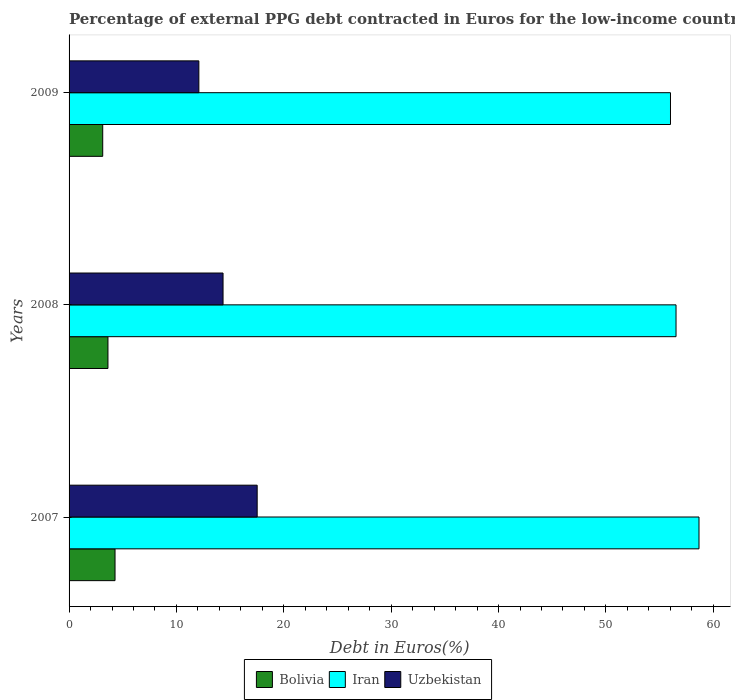How many different coloured bars are there?
Give a very brief answer. 3. How many bars are there on the 1st tick from the bottom?
Offer a very short reply. 3. In how many cases, is the number of bars for a given year not equal to the number of legend labels?
Your response must be concise. 0. What is the percentage of external PPG debt contracted in Euros in Bolivia in 2008?
Ensure brevity in your answer.  3.62. Across all years, what is the maximum percentage of external PPG debt contracted in Euros in Uzbekistan?
Ensure brevity in your answer.  17.52. Across all years, what is the minimum percentage of external PPG debt contracted in Euros in Iran?
Provide a succinct answer. 56.01. In which year was the percentage of external PPG debt contracted in Euros in Bolivia minimum?
Keep it short and to the point. 2009. What is the total percentage of external PPG debt contracted in Euros in Uzbekistan in the graph?
Ensure brevity in your answer.  43.95. What is the difference between the percentage of external PPG debt contracted in Euros in Uzbekistan in 2007 and that in 2008?
Your response must be concise. 3.18. What is the difference between the percentage of external PPG debt contracted in Euros in Iran in 2009 and the percentage of external PPG debt contracted in Euros in Bolivia in 2007?
Your response must be concise. 51.73. What is the average percentage of external PPG debt contracted in Euros in Iran per year?
Provide a short and direct response. 57.07. In the year 2007, what is the difference between the percentage of external PPG debt contracted in Euros in Bolivia and percentage of external PPG debt contracted in Euros in Iran?
Provide a succinct answer. -54.39. In how many years, is the percentage of external PPG debt contracted in Euros in Uzbekistan greater than 42 %?
Ensure brevity in your answer.  0. What is the ratio of the percentage of external PPG debt contracted in Euros in Iran in 2008 to that in 2009?
Ensure brevity in your answer.  1.01. Is the difference between the percentage of external PPG debt contracted in Euros in Bolivia in 2007 and 2009 greater than the difference between the percentage of external PPG debt contracted in Euros in Iran in 2007 and 2009?
Provide a short and direct response. No. What is the difference between the highest and the second highest percentage of external PPG debt contracted in Euros in Iran?
Your response must be concise. 2.14. What is the difference between the highest and the lowest percentage of external PPG debt contracted in Euros in Uzbekistan?
Offer a very short reply. 5.43. In how many years, is the percentage of external PPG debt contracted in Euros in Iran greater than the average percentage of external PPG debt contracted in Euros in Iran taken over all years?
Your answer should be very brief. 1. Is the sum of the percentage of external PPG debt contracted in Euros in Uzbekistan in 2008 and 2009 greater than the maximum percentage of external PPG debt contracted in Euros in Iran across all years?
Offer a very short reply. No. What does the 2nd bar from the top in 2008 represents?
Your answer should be compact. Iran. What does the 1st bar from the bottom in 2009 represents?
Your answer should be compact. Bolivia. Are all the bars in the graph horizontal?
Your response must be concise. Yes. How many years are there in the graph?
Provide a short and direct response. 3. What is the difference between two consecutive major ticks on the X-axis?
Your answer should be compact. 10. Are the values on the major ticks of X-axis written in scientific E-notation?
Provide a succinct answer. No. Does the graph contain any zero values?
Your answer should be compact. No. Where does the legend appear in the graph?
Your response must be concise. Bottom center. How many legend labels are there?
Keep it short and to the point. 3. How are the legend labels stacked?
Provide a short and direct response. Horizontal. What is the title of the graph?
Give a very brief answer. Percentage of external PPG debt contracted in Euros for the low-income countries. Does "Sub-Saharan Africa (developing only)" appear as one of the legend labels in the graph?
Your response must be concise. No. What is the label or title of the X-axis?
Offer a terse response. Debt in Euros(%). What is the Debt in Euros(%) in Bolivia in 2007?
Offer a terse response. 4.28. What is the Debt in Euros(%) of Iran in 2007?
Ensure brevity in your answer.  58.67. What is the Debt in Euros(%) in Uzbekistan in 2007?
Provide a succinct answer. 17.52. What is the Debt in Euros(%) of Bolivia in 2008?
Offer a very short reply. 3.62. What is the Debt in Euros(%) in Iran in 2008?
Make the answer very short. 56.53. What is the Debt in Euros(%) of Uzbekistan in 2008?
Give a very brief answer. 14.34. What is the Debt in Euros(%) of Bolivia in 2009?
Offer a very short reply. 3.13. What is the Debt in Euros(%) in Iran in 2009?
Your response must be concise. 56.01. What is the Debt in Euros(%) of Uzbekistan in 2009?
Offer a terse response. 12.09. Across all years, what is the maximum Debt in Euros(%) in Bolivia?
Give a very brief answer. 4.28. Across all years, what is the maximum Debt in Euros(%) in Iran?
Ensure brevity in your answer.  58.67. Across all years, what is the maximum Debt in Euros(%) in Uzbekistan?
Offer a very short reply. 17.52. Across all years, what is the minimum Debt in Euros(%) of Bolivia?
Make the answer very short. 3.13. Across all years, what is the minimum Debt in Euros(%) in Iran?
Give a very brief answer. 56.01. Across all years, what is the minimum Debt in Euros(%) of Uzbekistan?
Keep it short and to the point. 12.09. What is the total Debt in Euros(%) in Bolivia in the graph?
Your response must be concise. 11.04. What is the total Debt in Euros(%) of Iran in the graph?
Your answer should be compact. 171.21. What is the total Debt in Euros(%) in Uzbekistan in the graph?
Provide a succinct answer. 43.95. What is the difference between the Debt in Euros(%) in Bolivia in 2007 and that in 2008?
Provide a short and direct response. 0.66. What is the difference between the Debt in Euros(%) of Iran in 2007 and that in 2008?
Offer a very short reply. 2.14. What is the difference between the Debt in Euros(%) in Uzbekistan in 2007 and that in 2008?
Make the answer very short. 3.18. What is the difference between the Debt in Euros(%) in Bolivia in 2007 and that in 2009?
Ensure brevity in your answer.  1.15. What is the difference between the Debt in Euros(%) in Iran in 2007 and that in 2009?
Provide a short and direct response. 2.66. What is the difference between the Debt in Euros(%) in Uzbekistan in 2007 and that in 2009?
Provide a succinct answer. 5.43. What is the difference between the Debt in Euros(%) in Bolivia in 2008 and that in 2009?
Provide a short and direct response. 0.49. What is the difference between the Debt in Euros(%) of Iran in 2008 and that in 2009?
Your answer should be compact. 0.52. What is the difference between the Debt in Euros(%) of Uzbekistan in 2008 and that in 2009?
Make the answer very short. 2.25. What is the difference between the Debt in Euros(%) of Bolivia in 2007 and the Debt in Euros(%) of Iran in 2008?
Provide a short and direct response. -52.25. What is the difference between the Debt in Euros(%) in Bolivia in 2007 and the Debt in Euros(%) in Uzbekistan in 2008?
Make the answer very short. -10.06. What is the difference between the Debt in Euros(%) of Iran in 2007 and the Debt in Euros(%) of Uzbekistan in 2008?
Make the answer very short. 44.33. What is the difference between the Debt in Euros(%) of Bolivia in 2007 and the Debt in Euros(%) of Iran in 2009?
Offer a very short reply. -51.73. What is the difference between the Debt in Euros(%) in Bolivia in 2007 and the Debt in Euros(%) in Uzbekistan in 2009?
Give a very brief answer. -7.81. What is the difference between the Debt in Euros(%) of Iran in 2007 and the Debt in Euros(%) of Uzbekistan in 2009?
Your answer should be compact. 46.58. What is the difference between the Debt in Euros(%) in Bolivia in 2008 and the Debt in Euros(%) in Iran in 2009?
Make the answer very short. -52.39. What is the difference between the Debt in Euros(%) in Bolivia in 2008 and the Debt in Euros(%) in Uzbekistan in 2009?
Offer a very short reply. -8.47. What is the difference between the Debt in Euros(%) in Iran in 2008 and the Debt in Euros(%) in Uzbekistan in 2009?
Offer a very short reply. 44.44. What is the average Debt in Euros(%) in Bolivia per year?
Make the answer very short. 3.68. What is the average Debt in Euros(%) of Iran per year?
Your answer should be compact. 57.07. What is the average Debt in Euros(%) in Uzbekistan per year?
Your answer should be compact. 14.65. In the year 2007, what is the difference between the Debt in Euros(%) in Bolivia and Debt in Euros(%) in Iran?
Your answer should be very brief. -54.39. In the year 2007, what is the difference between the Debt in Euros(%) in Bolivia and Debt in Euros(%) in Uzbekistan?
Provide a succinct answer. -13.24. In the year 2007, what is the difference between the Debt in Euros(%) of Iran and Debt in Euros(%) of Uzbekistan?
Offer a terse response. 41.15. In the year 2008, what is the difference between the Debt in Euros(%) of Bolivia and Debt in Euros(%) of Iran?
Keep it short and to the point. -52.91. In the year 2008, what is the difference between the Debt in Euros(%) of Bolivia and Debt in Euros(%) of Uzbekistan?
Provide a short and direct response. -10.72. In the year 2008, what is the difference between the Debt in Euros(%) in Iran and Debt in Euros(%) in Uzbekistan?
Your answer should be very brief. 42.19. In the year 2009, what is the difference between the Debt in Euros(%) in Bolivia and Debt in Euros(%) in Iran?
Keep it short and to the point. -52.88. In the year 2009, what is the difference between the Debt in Euros(%) in Bolivia and Debt in Euros(%) in Uzbekistan?
Ensure brevity in your answer.  -8.95. In the year 2009, what is the difference between the Debt in Euros(%) in Iran and Debt in Euros(%) in Uzbekistan?
Provide a succinct answer. 43.93. What is the ratio of the Debt in Euros(%) of Bolivia in 2007 to that in 2008?
Provide a succinct answer. 1.18. What is the ratio of the Debt in Euros(%) of Iran in 2007 to that in 2008?
Keep it short and to the point. 1.04. What is the ratio of the Debt in Euros(%) in Uzbekistan in 2007 to that in 2008?
Offer a terse response. 1.22. What is the ratio of the Debt in Euros(%) in Bolivia in 2007 to that in 2009?
Give a very brief answer. 1.37. What is the ratio of the Debt in Euros(%) in Iran in 2007 to that in 2009?
Your answer should be very brief. 1.05. What is the ratio of the Debt in Euros(%) of Uzbekistan in 2007 to that in 2009?
Give a very brief answer. 1.45. What is the ratio of the Debt in Euros(%) in Bolivia in 2008 to that in 2009?
Ensure brevity in your answer.  1.16. What is the ratio of the Debt in Euros(%) in Iran in 2008 to that in 2009?
Provide a short and direct response. 1.01. What is the ratio of the Debt in Euros(%) in Uzbekistan in 2008 to that in 2009?
Make the answer very short. 1.19. What is the difference between the highest and the second highest Debt in Euros(%) in Bolivia?
Give a very brief answer. 0.66. What is the difference between the highest and the second highest Debt in Euros(%) of Iran?
Give a very brief answer. 2.14. What is the difference between the highest and the second highest Debt in Euros(%) of Uzbekistan?
Make the answer very short. 3.18. What is the difference between the highest and the lowest Debt in Euros(%) of Bolivia?
Your answer should be compact. 1.15. What is the difference between the highest and the lowest Debt in Euros(%) of Iran?
Your response must be concise. 2.66. What is the difference between the highest and the lowest Debt in Euros(%) in Uzbekistan?
Offer a very short reply. 5.43. 